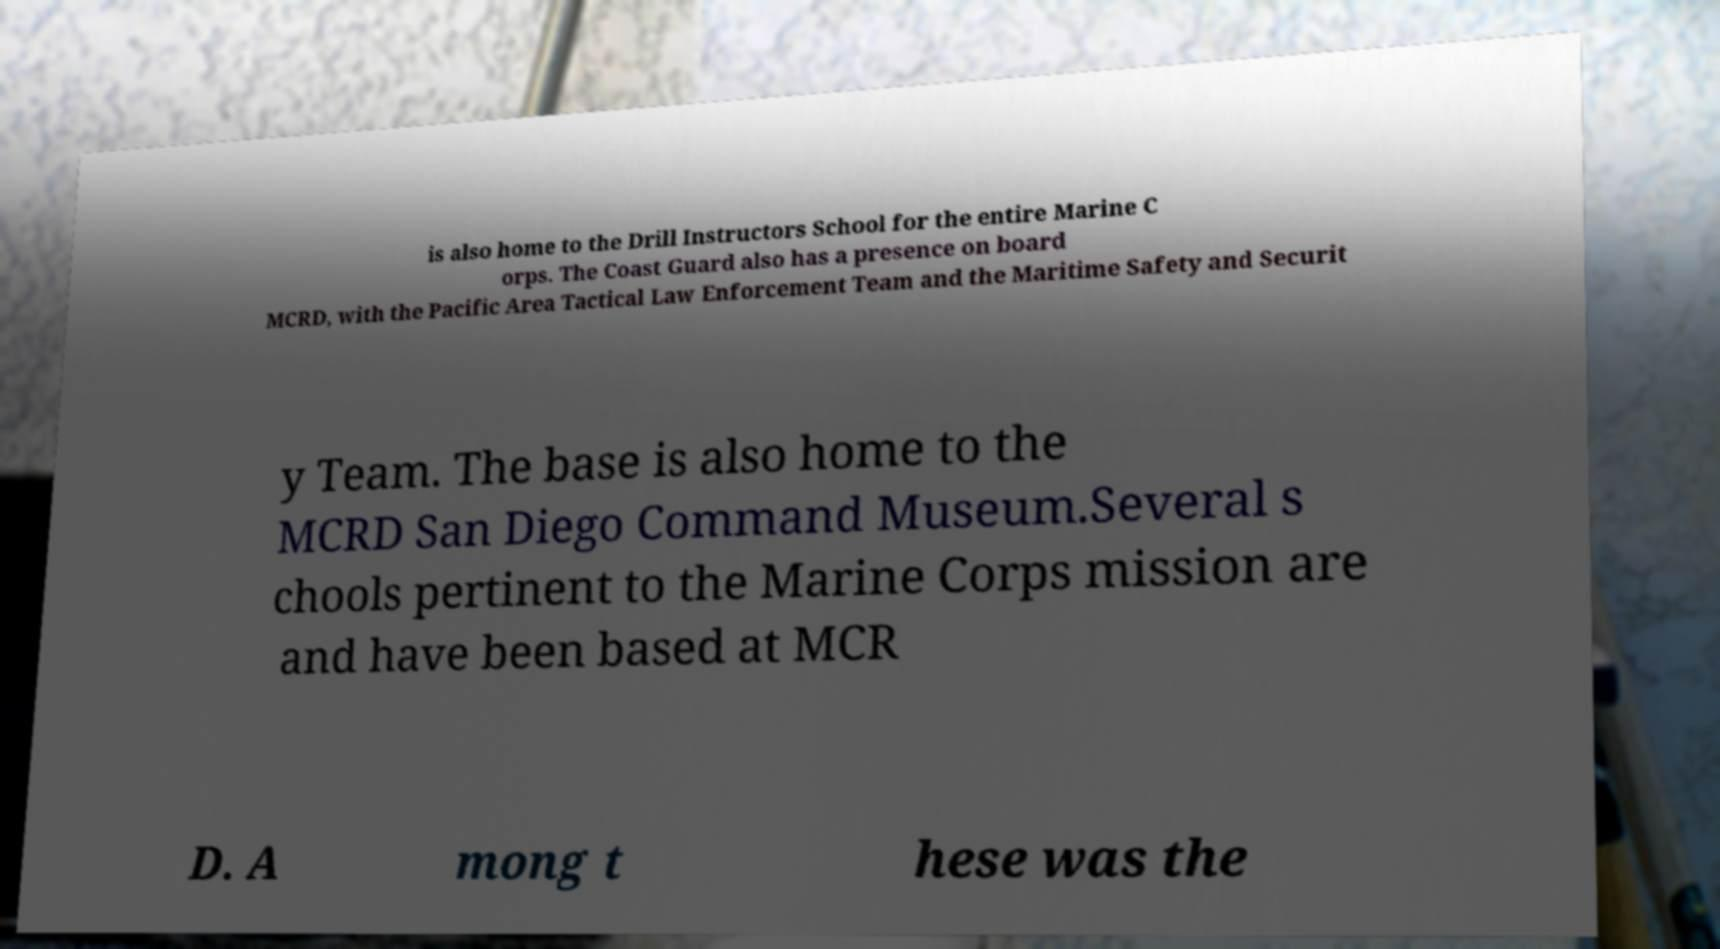For documentation purposes, I need the text within this image transcribed. Could you provide that? is also home to the Drill Instructors School for the entire Marine C orps. The Coast Guard also has a presence on board MCRD, with the Pacific Area Tactical Law Enforcement Team and the Maritime Safety and Securit y Team. The base is also home to the MCRD San Diego Command Museum.Several s chools pertinent to the Marine Corps mission are and have been based at MCR D. A mong t hese was the 